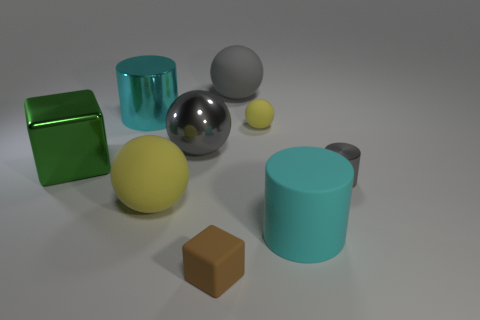Subtract all cyan cylinders. How many cylinders are left? 1 Subtract all green spheres. Subtract all blue cylinders. How many spheres are left? 4 Subtract all balls. How many objects are left? 5 Add 9 big green shiny cubes. How many big green shiny cubes are left? 10 Add 6 small brown objects. How many small brown objects exist? 7 Subtract 0 yellow blocks. How many objects are left? 9 Subtract all cyan balls. Subtract all yellow matte balls. How many objects are left? 7 